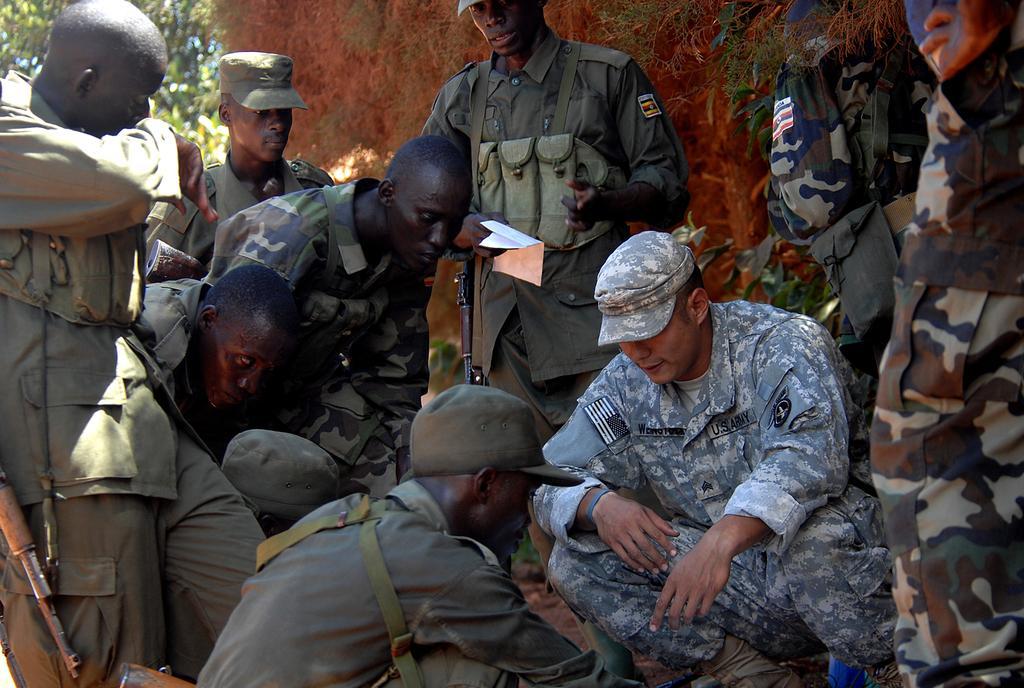In one or two sentences, can you explain what this image depicts? In this image we can see people wearing uniforms. The man standing in the center is holding a paper and there are rifles. In the background there are trees and a wall. 